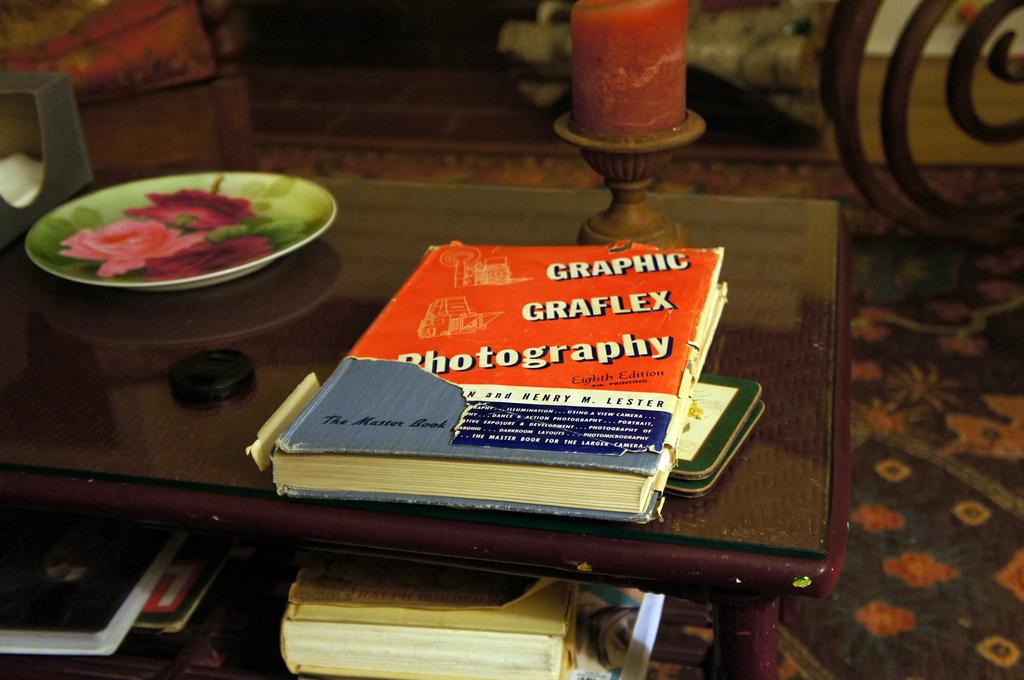Will this graphic,graflex, photography book use full for photographers ?
Give a very brief answer. Yes. Did henry m lester help write this?
Your response must be concise. Yes. 